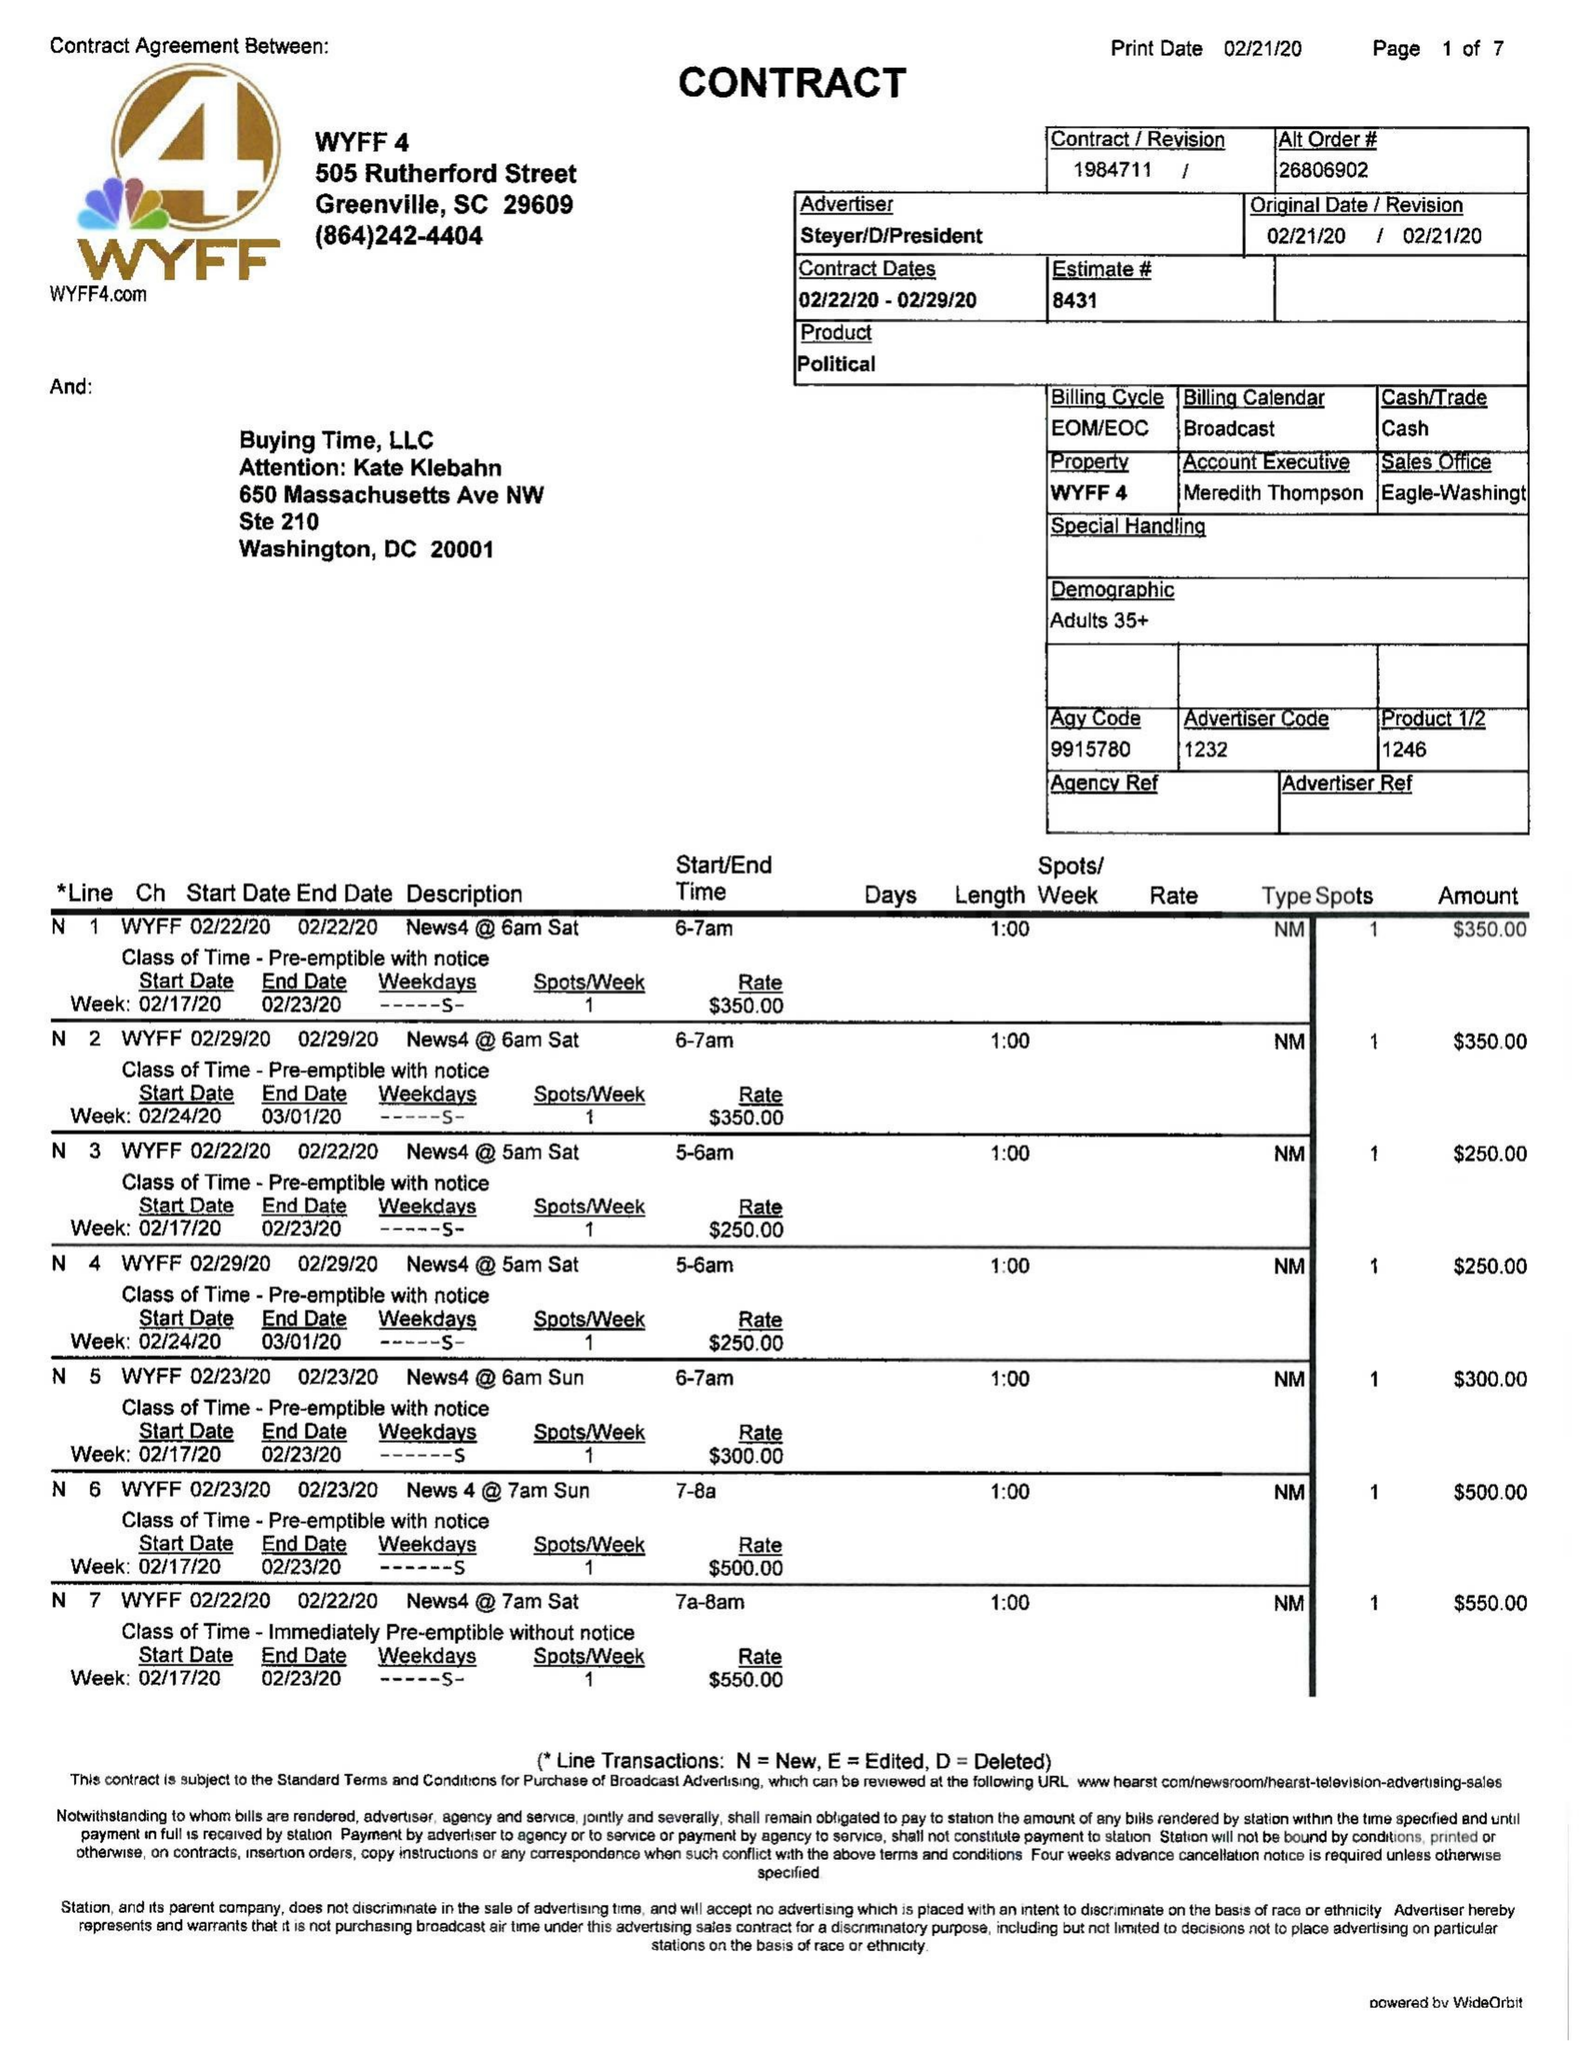What is the value for the gross_amount?
Answer the question using a single word or phrase. 31550.00 